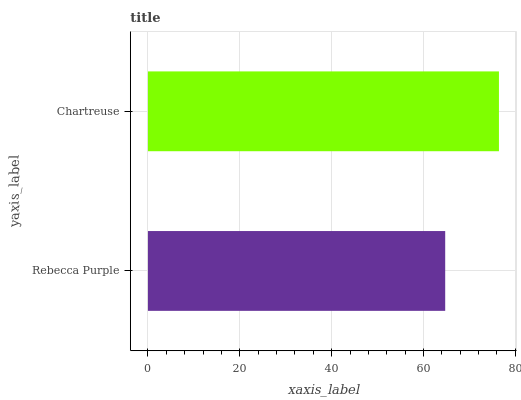Is Rebecca Purple the minimum?
Answer yes or no. Yes. Is Chartreuse the maximum?
Answer yes or no. Yes. Is Chartreuse the minimum?
Answer yes or no. No. Is Chartreuse greater than Rebecca Purple?
Answer yes or no. Yes. Is Rebecca Purple less than Chartreuse?
Answer yes or no. Yes. Is Rebecca Purple greater than Chartreuse?
Answer yes or no. No. Is Chartreuse less than Rebecca Purple?
Answer yes or no. No. Is Chartreuse the high median?
Answer yes or no. Yes. Is Rebecca Purple the low median?
Answer yes or no. Yes. Is Rebecca Purple the high median?
Answer yes or no. No. Is Chartreuse the low median?
Answer yes or no. No. 